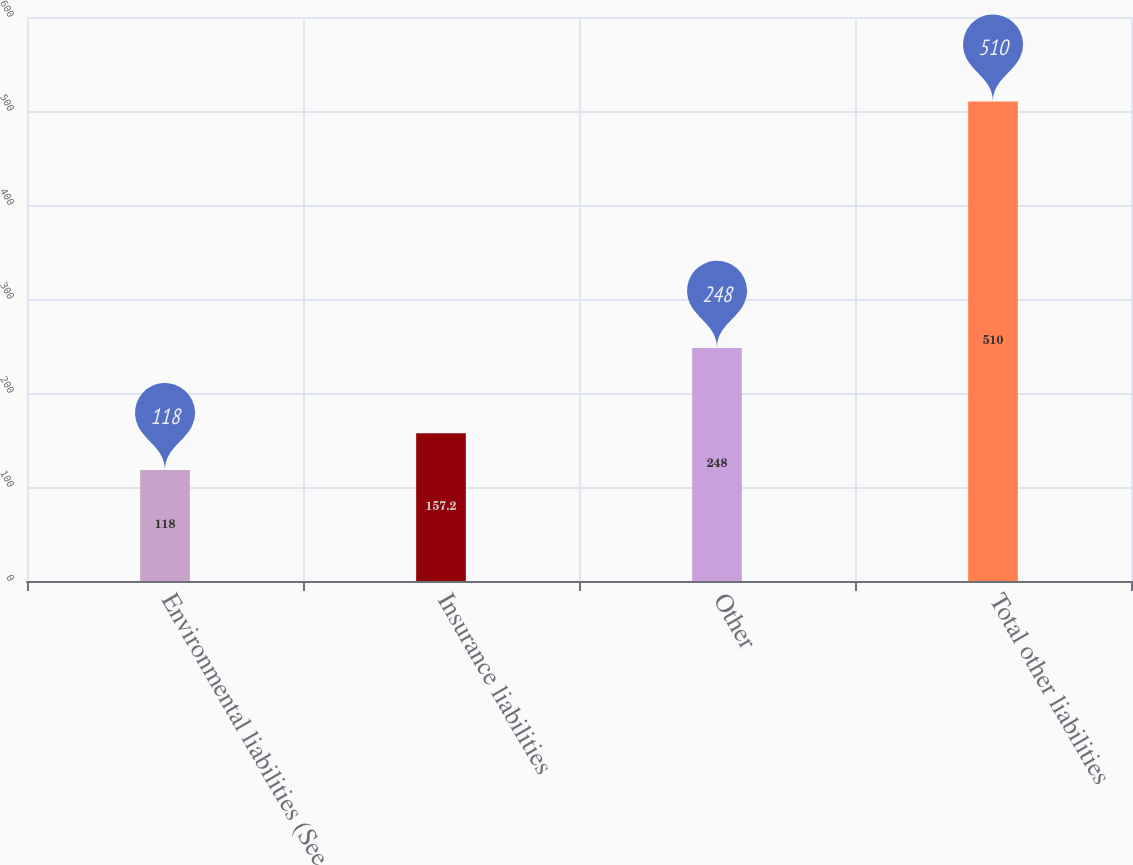Convert chart to OTSL. <chart><loc_0><loc_0><loc_500><loc_500><bar_chart><fcel>Environmental liabilities (See<fcel>Insurance liabilities<fcel>Other<fcel>Total other liabilities<nl><fcel>118<fcel>157.2<fcel>248<fcel>510<nl></chart> 